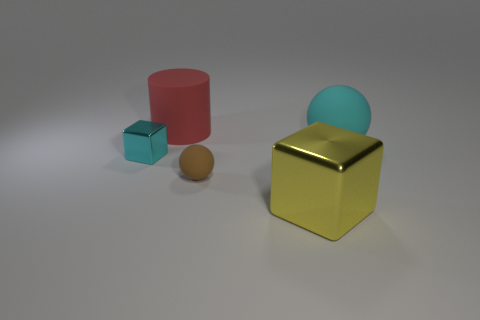Add 1 large cyan things. How many objects exist? 6 Subtract all spheres. How many objects are left? 3 Subtract all metallic blocks. Subtract all shiny blocks. How many objects are left? 1 Add 3 small brown things. How many small brown things are left? 4 Add 3 brown objects. How many brown objects exist? 4 Subtract 0 blue balls. How many objects are left? 5 